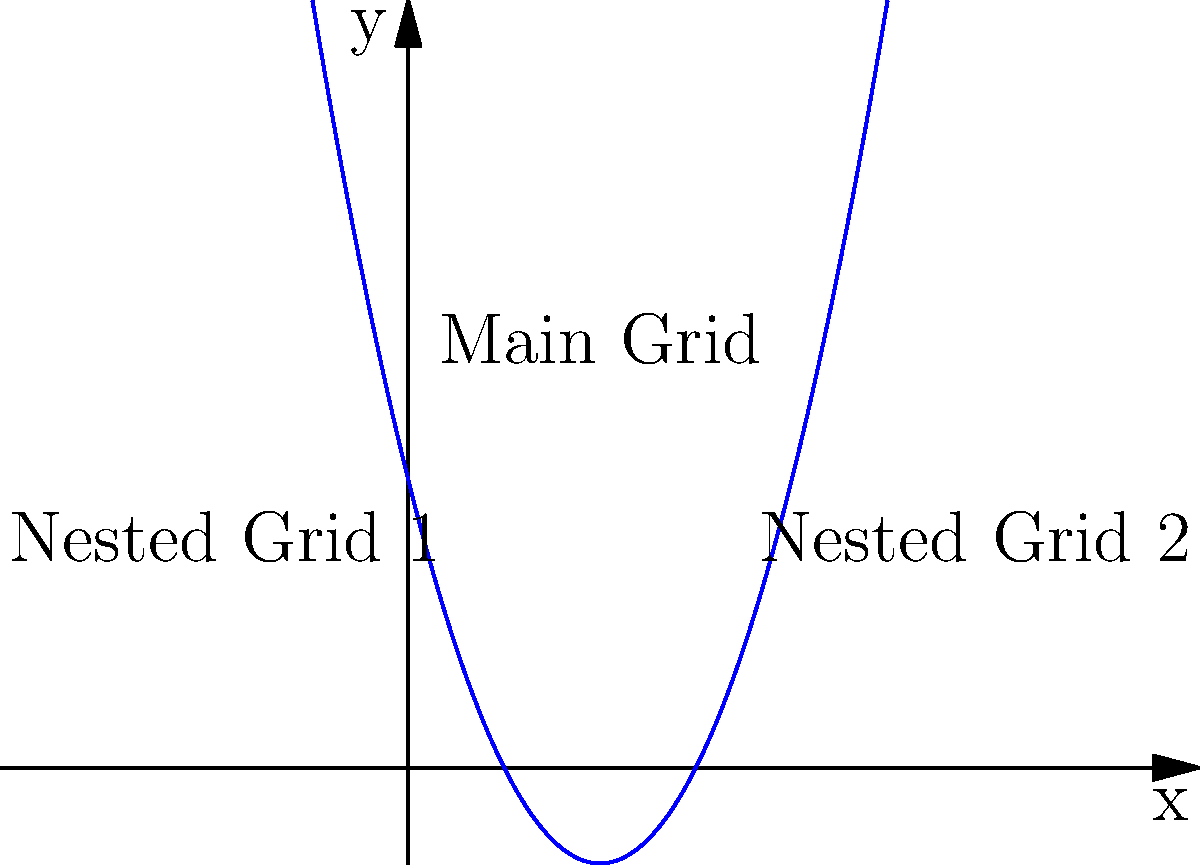In a CSS Grid layout for a project management dashboard, you want to create a nested grid structure. The main grid represents the overall dashboard layout, while two nested grids represent different sections of the dashboard. If the main grid is defined by the function $f(x) = x^2 - 4x + 3$, and the nested grids are positioned at $x = 0.5$ and $x = 3.5$, what is the total vertical space (in grid units) occupied by both nested grids combined? To solve this problem, we need to follow these steps:

1. Identify the function for the main grid: $f(x) = x^2 - 4x + 3$

2. Calculate the y-value (height) for Nested Grid 1 at $x = 0.5$:
   $f(0.5) = (0.5)^2 - 4(0.5) + 3$
   $= 0.25 - 2 + 3 = 1.25$

3. Calculate the y-value (height) for Nested Grid 2 at $x = 3.5$:
   $f(3.5) = (3.5)^2 - 4(3.5) + 3$
   $= 12.25 - 14 + 3 = 1.25$

4. Sum the heights of both nested grids:
   Total vertical space = $1.25 + 1.25 = 2.5$ grid units

This calculation shows that both nested grids occupy a total of 2.5 grid units in vertical space within the main grid structure of the project management dashboard.
Answer: 2.5 grid units 